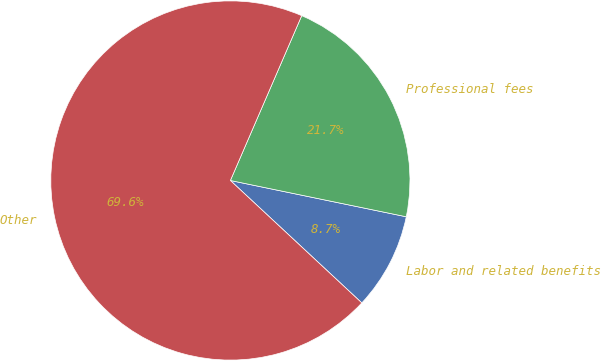Convert chart. <chart><loc_0><loc_0><loc_500><loc_500><pie_chart><fcel>Labor and related benefits<fcel>Professional fees<fcel>Other<nl><fcel>8.7%<fcel>21.74%<fcel>69.57%<nl></chart> 